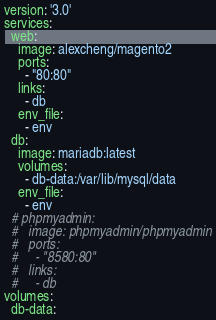Convert code to text. <code><loc_0><loc_0><loc_500><loc_500><_YAML_>version: '3.0'
services:
  web:
    image: alexcheng/magento2
    ports:
      - "80:80"
    links:
      - db
    env_file:
      - env
  db:
    image: mariadb:latest
    volumes:
      - db-data:/var/lib/mysql/data
    env_file:
      - env
  # phpmyadmin:
  #   image: phpmyadmin/phpmyadmin
  #   ports:
  #     - "8580:80"
  #   links:
  #     - db
volumes:
  db-data:
</code> 